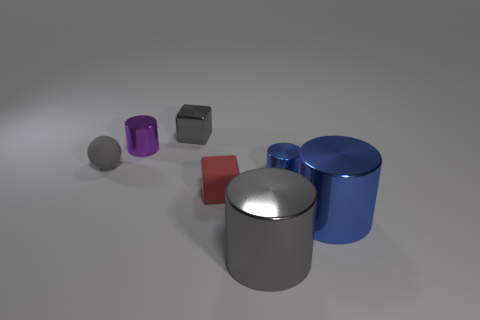The other cube that is the same size as the gray metallic block is what color?
Provide a short and direct response. Red. What number of metallic things are either blue things or big gray things?
Give a very brief answer. 3. What number of large blue things are in front of the small metal thing that is left of the metal cube?
Make the answer very short. 1. What size is the matte object that is the same color as the tiny metal cube?
Provide a short and direct response. Small. What number of objects are metallic things or small gray spheres to the left of the tiny red object?
Keep it short and to the point. 6. Are there any tiny blue objects that have the same material as the purple thing?
Provide a short and direct response. Yes. What number of cylinders are both in front of the large blue metal cylinder and behind the tiny gray matte object?
Offer a very short reply. 0. What is the material of the cylinder that is left of the shiny block?
Keep it short and to the point. Metal. What is the size of the gray cube that is made of the same material as the gray cylinder?
Provide a succinct answer. Small. Are there any small matte blocks to the left of the small blue shiny thing?
Offer a terse response. Yes. 